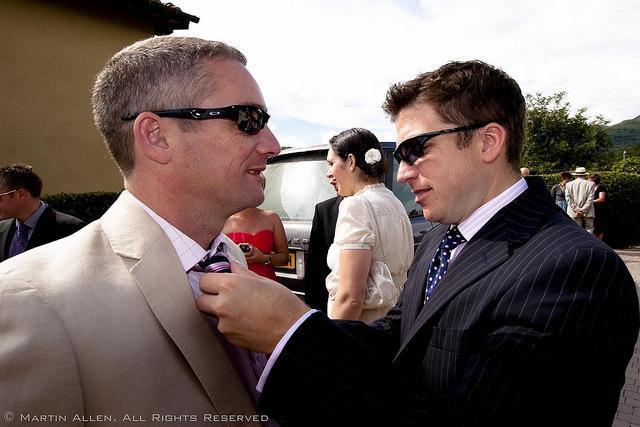How many people are visible?
Give a very brief answer. 6. How many giraffes are there?
Give a very brief answer. 0. 